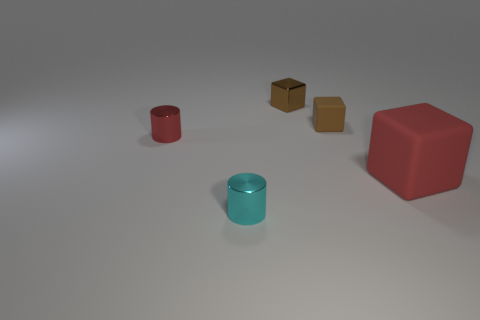Are there any other things that are the same size as the red cube?
Provide a short and direct response. No. Does the tiny thing that is to the left of the tiny cyan metal object have the same material as the small cube that is in front of the tiny metal block?
Provide a short and direct response. No. How big is the metal thing in front of the tiny metallic cylinder that is behind the tiny cyan cylinder?
Your response must be concise. Small. What material is the red object right of the tiny brown matte cube?
Keep it short and to the point. Rubber. What number of things are cubes behind the red block or tiny objects that are behind the cyan metal object?
Your answer should be compact. 3. What is the material of the red thing that is the same shape as the tiny brown matte object?
Offer a very short reply. Rubber. Does the small metallic thing behind the small brown matte thing have the same color as the matte cube that is behind the red shiny object?
Make the answer very short. Yes. Is there a metallic object of the same size as the brown matte thing?
Give a very brief answer. Yes. There is a tiny object that is in front of the brown shiny block and behind the red cylinder; what is it made of?
Your answer should be very brief. Rubber. What number of shiny objects are large red things or purple balls?
Offer a terse response. 0. 